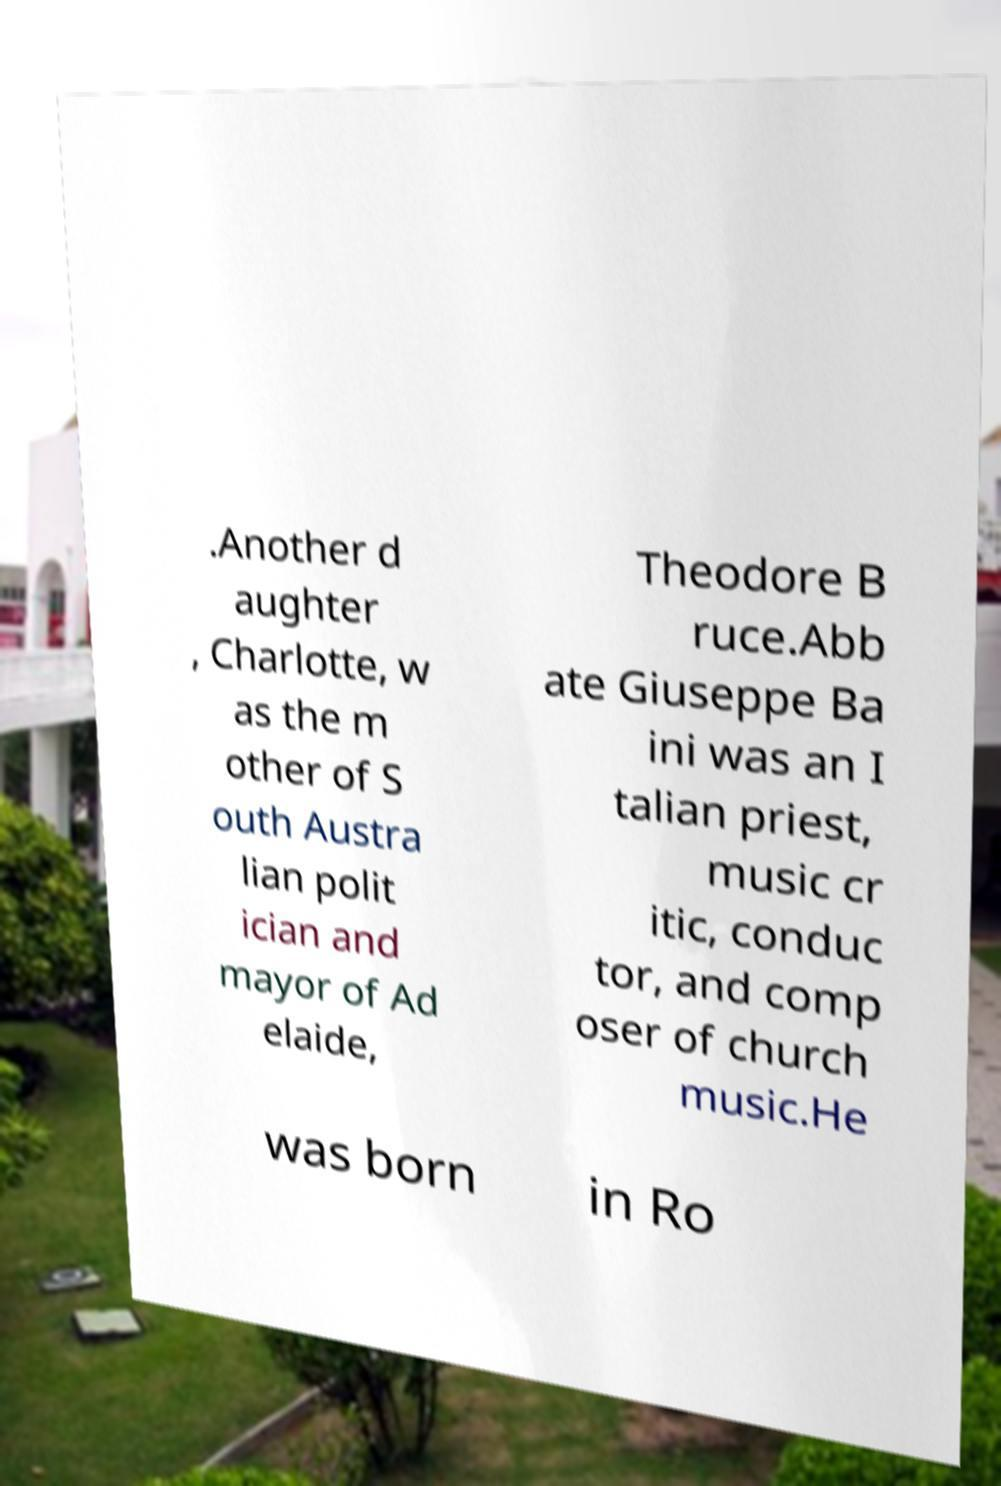Can you accurately transcribe the text from the provided image for me? .Another d aughter , Charlotte, w as the m other of S outh Austra lian polit ician and mayor of Ad elaide, Theodore B ruce.Abb ate Giuseppe Ba ini was an I talian priest, music cr itic, conduc tor, and comp oser of church music.He was born in Ro 